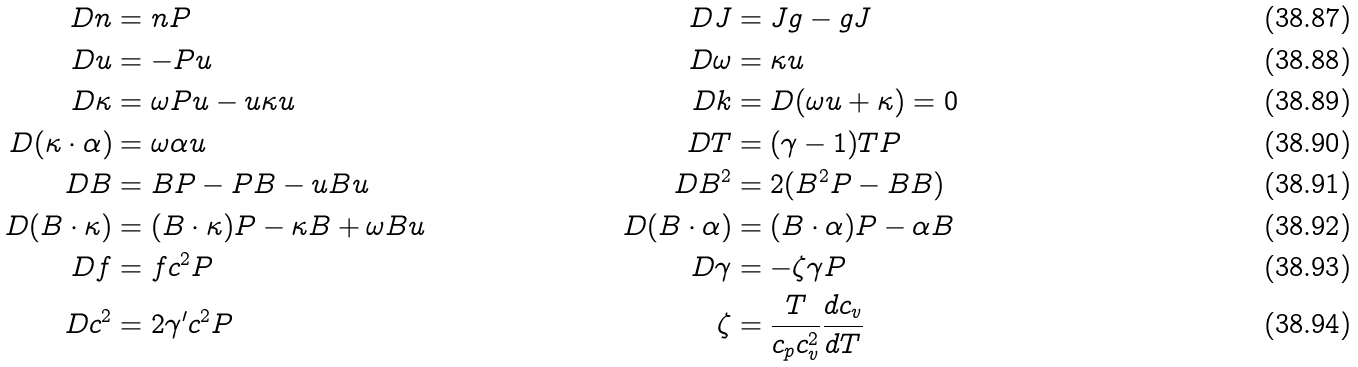<formula> <loc_0><loc_0><loc_500><loc_500>D n & = n P & D J & = J g - g J \\ D u & = - P u & D \omega & = \kappa u \\ D \kappa & = \omega P u - u \kappa u & D k & = D ( \omega u + \kappa ) = 0 \\ D ( \kappa \cdot \alpha ) & = \omega \alpha u & D T & = ( \gamma - 1 ) T P & \\ D B & = B P - P B - u B u & D B ^ { 2 } & = 2 ( B ^ { 2 } P - B B ) \\ D ( B \cdot \kappa ) & = ( B \cdot \kappa ) P - \kappa B + \omega B u & D ( B \cdot \alpha ) & = ( B \cdot \alpha ) P - \alpha B \\ D f & = f c ^ { 2 } P & D \gamma & = - \zeta \gamma P \\ D c ^ { 2 } & = 2 \gamma ^ { \prime } c ^ { 2 } P & \zeta & = \frac { T } { c _ { p } c _ { v } ^ { 2 } } \frac { d c _ { v } } { d T }</formula> 